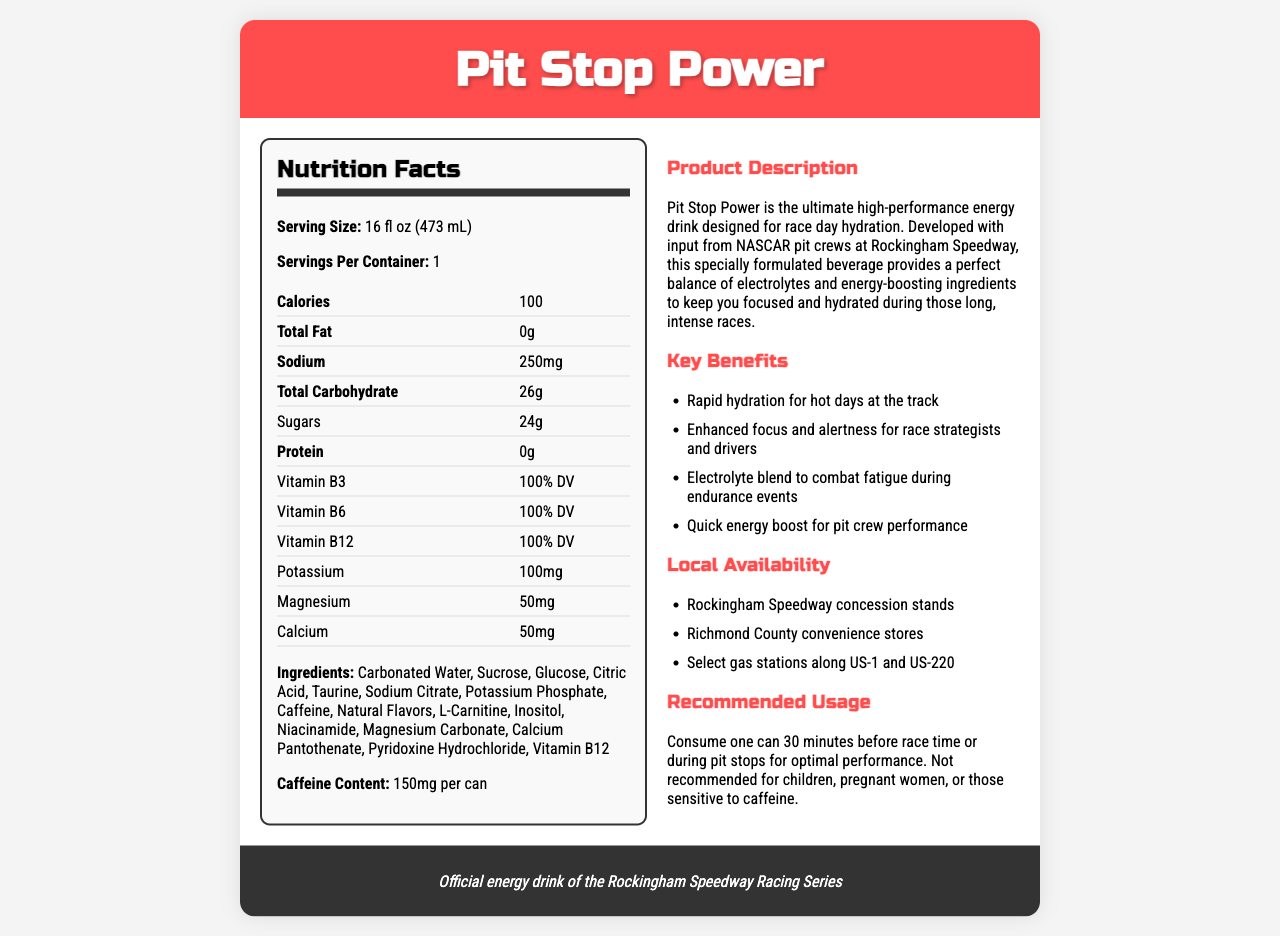what is the serving size of Pit Stop Power? The serving size specified in the document is 16 fl oz (473 mL).
Answer: 16 fl oz (473 mL) how many calories are in one serving of Pit Stop Power? The document indicates that there are 100 calories per serving.
Answer: 100 what is the total fat content in Pit Stop Power? According to the nutrition facts, the total fat content is 0g.
Answer: 0g how much sodium does Pit Stop Power contain per can? The sodium content per serving (which is one can) is 250mg.
Answer: 250mg what is the primary purpose of Pit Stop Power as mentioned in the product description? The product description states that Pit Stop Power is designed for race day hydration.
Answer: Race day hydration what are the four vitamins and minerals listed with their percent daily values? (Multiple Choice) A. Vitamin C, Vitamin E, Vitamin K, Iron B. Vitamin B3, Vitamin B6, Vitamin B12, Calcium C. Vitamin A, Calcium, Magnesium, Potassium D. Vitamin D, Iron, Zinc, Folate The document lists Vitamin B3 (100% DV), Vitamin B6 (100% DV), Vitamin B12 (100% DV), and Calcium (50mg) with their daily values.
Answer: B where can you buy Pit Stop Power locally? (Multiple Choice) I. Grocery Stores II. Gas stations on US-1 and US-220 III. Online Retailers IV. Concession stands at Rockingham Speedway The document mentions that Pit Stop Power is available at Rockingham Speedway concession stands and select gas stations along US-1 and US-220.
Answer: II, IV is Pit Stop Power recommended for children? The recommended usage explicitly states that it is not recommended for children.
Answer: No summarize the main idea of the document The document provides detailed nutrition information, product description, key benefits, local availability, and usage recommendations for Pit Stop Power, emphasizing its use for race day hydration and performance.
Answer: Pit Stop Power is a high-performance energy drink specifically designed for race day hydration, endorsed by NASCAR, and available at selected local spots in Rockingham. It contains 100 calories, essential vitamins, minerals, and a high caffeine content to boost energy and focus during intense races. does Pit Stop Power contain caffeine? The document lists caffeine as an ingredient and mentions a caffeine content of 150mg per can.
Answer: Yes which ingredient in Pit Stop Power is responsible for providing rapid hydration? The product description mentions rapid hydration and the ingredients Sodium Citrate and Potassium Phosphate contribute to electrolyte balance for rapid hydration.
Answer: electrolytes (Sodium Citrate, Potassium Phosphate) who developed Pit Stop Power? The product description states that the beverage was developed with input from NASCAR pit crews at Rockingham Speedway.
Answer: NASCAR pit crews at Rockingham Speedway how many grams of sugars are in one serving of Pit Stop Power? The nutrition facts indicate that there are 24 grams of sugars per serving.
Answer: 24g what is the main energy-boosting ingredient in Pit Stop Power? According to the ingredients list, caffeine is the primary energy-boosting ingredient.
Answer: Caffeine what is the recommended usage time for optimal performance? The recommended usage section advises consuming one can 30 minutes before race time or during pit stops for optimal performance.
Answer: 30 minutes before race time or during pit stops who endorses Pit Stop Power? (Multiple Choice) 1. Professional Athletes 2. International Sports Federation 3. Rockingham Speedway Racing Series 4. Local Health Authority The document mentions that Pit Stop Power is the official energy drink of the Rockingham Speedway Racing Series.
Answer: 3 what is the caffeine content per serving of Pit Stop Power? The document specifies that the caffeine content is 150mg per can.
Answer: 150mg per can are there any ingredients in Pit Stop Power not listed in the document? The document lists the ingredients that are included, but it doesn't state whether this is a complete or partial list.
Answer: Cannot be determined 